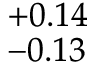<formula> <loc_0><loc_0><loc_500><loc_500>^ { + 0 . 1 4 } _ { - 0 . 1 3 }</formula> 